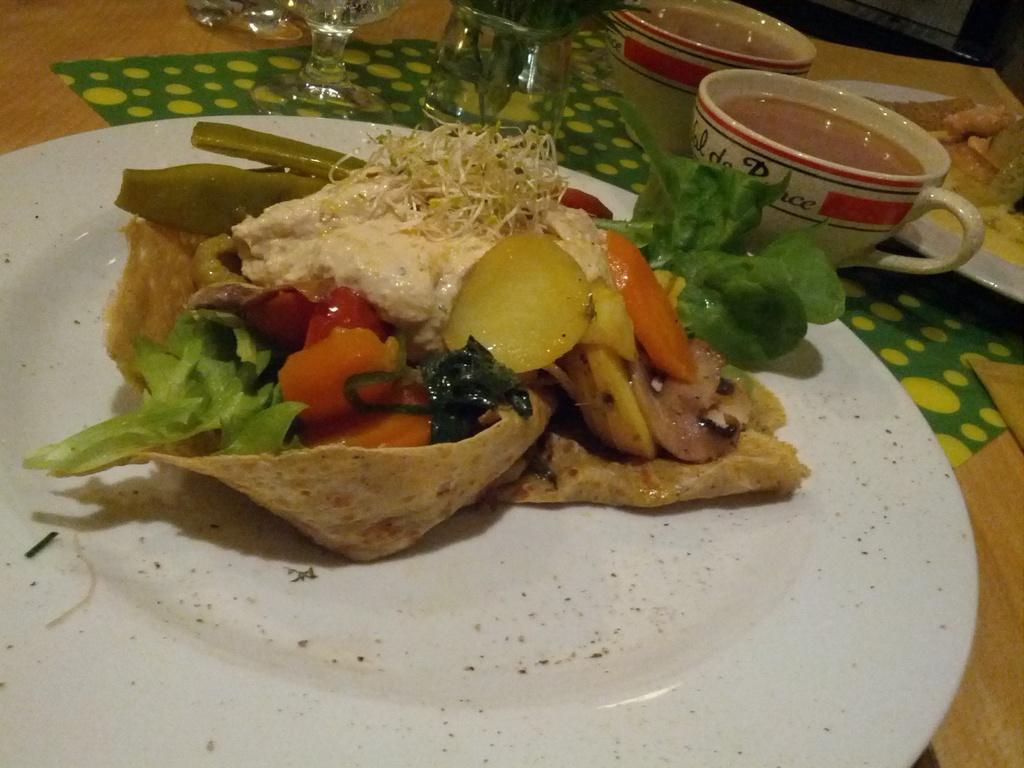In one or two sentences, can you explain what this image depicts? As we can see in the image there is a table. On table there are plates cups, glasses and dishes. 